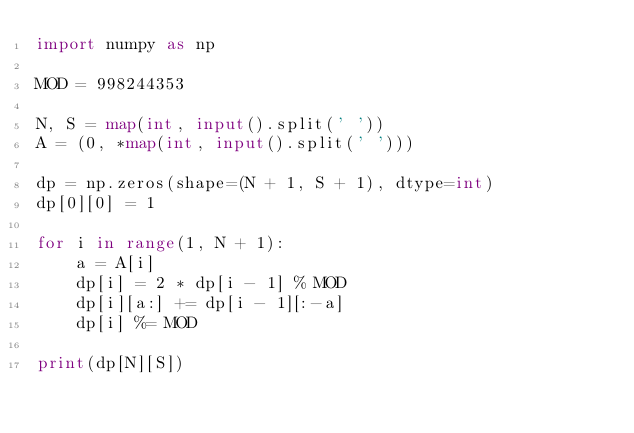Convert code to text. <code><loc_0><loc_0><loc_500><loc_500><_Python_>import numpy as np

MOD = 998244353

N, S = map(int, input().split(' '))
A = (0, *map(int, input().split(' ')))

dp = np.zeros(shape=(N + 1, S + 1), dtype=int)
dp[0][0] = 1

for i in range(1, N + 1):
    a = A[i]
    dp[i] = 2 * dp[i - 1] % MOD
    dp[i][a:] += dp[i - 1][:-a]
    dp[i] %= MOD

print(dp[N][S])
</code> 